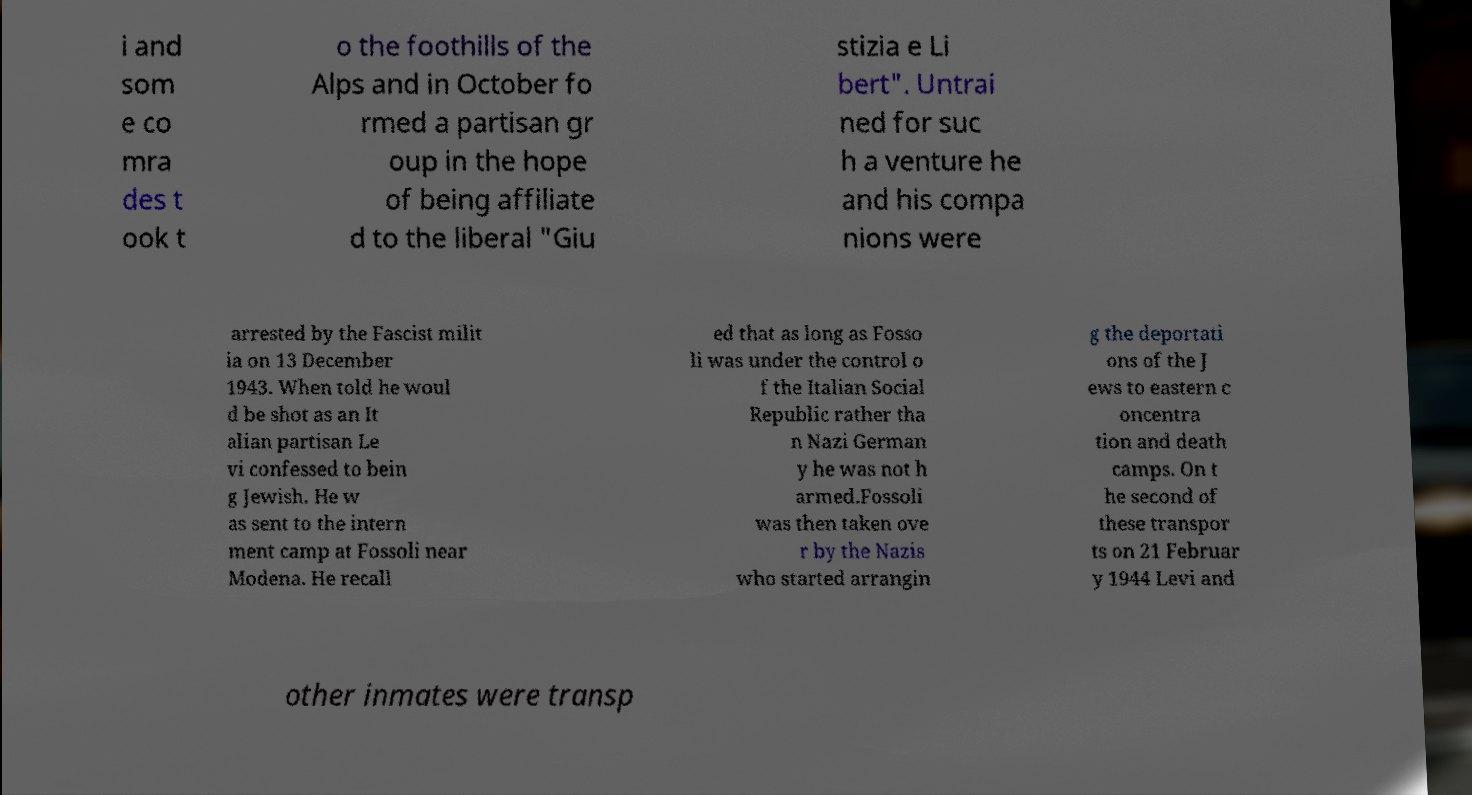For documentation purposes, I need the text within this image transcribed. Could you provide that? i and som e co mra des t ook t o the foothills of the Alps and in October fo rmed a partisan gr oup in the hope of being affiliate d to the liberal "Giu stizia e Li bert". Untrai ned for suc h a venture he and his compa nions were arrested by the Fascist milit ia on 13 December 1943. When told he woul d be shot as an It alian partisan Le vi confessed to bein g Jewish. He w as sent to the intern ment camp at Fossoli near Modena. He recall ed that as long as Fosso li was under the control o f the Italian Social Republic rather tha n Nazi German y he was not h armed.Fossoli was then taken ove r by the Nazis who started arrangin g the deportati ons of the J ews to eastern c oncentra tion and death camps. On t he second of these transpor ts on 21 Februar y 1944 Levi and other inmates were transp 